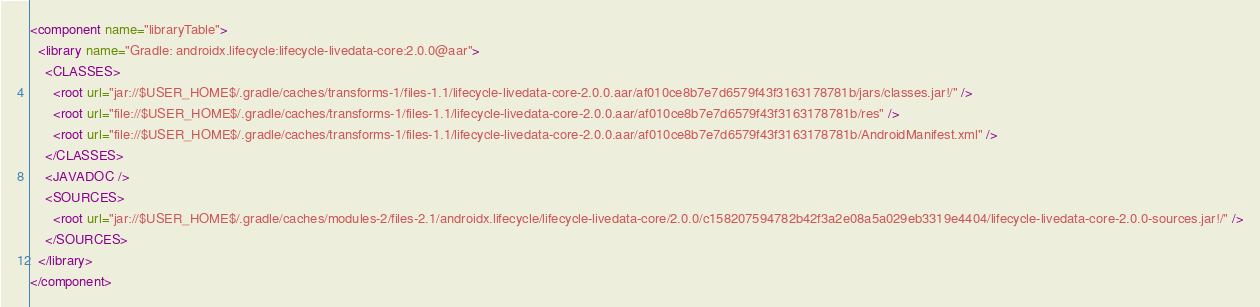<code> <loc_0><loc_0><loc_500><loc_500><_XML_><component name="libraryTable">
  <library name="Gradle: androidx.lifecycle:lifecycle-livedata-core:2.0.0@aar">
    <CLASSES>
      <root url="jar://$USER_HOME$/.gradle/caches/transforms-1/files-1.1/lifecycle-livedata-core-2.0.0.aar/af010ce8b7e7d6579f43f3163178781b/jars/classes.jar!/" />
      <root url="file://$USER_HOME$/.gradle/caches/transforms-1/files-1.1/lifecycle-livedata-core-2.0.0.aar/af010ce8b7e7d6579f43f3163178781b/res" />
      <root url="file://$USER_HOME$/.gradle/caches/transforms-1/files-1.1/lifecycle-livedata-core-2.0.0.aar/af010ce8b7e7d6579f43f3163178781b/AndroidManifest.xml" />
    </CLASSES>
    <JAVADOC />
    <SOURCES>
      <root url="jar://$USER_HOME$/.gradle/caches/modules-2/files-2.1/androidx.lifecycle/lifecycle-livedata-core/2.0.0/c158207594782b42f3a2e08a5a029eb3319e4404/lifecycle-livedata-core-2.0.0-sources.jar!/" />
    </SOURCES>
  </library>
</component></code> 